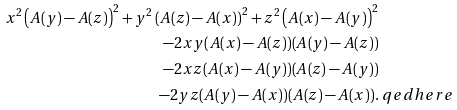Convert formula to latex. <formula><loc_0><loc_0><loc_500><loc_500>x ^ { 2 } \left ( A ( y ) - A ( z ) \right ) ^ { 2 } + y ^ { 2 } \left ( A ( z ) - A ( x ) \right ) ^ { 2 } + z ^ { 2 } \left ( A ( x ) - A ( y ) \right ) ^ { 2 } & \\ - 2 x y ( A ( x ) - A ( z ) ) ( A ( y ) - A ( z ) ) & \\ - 2 x z ( A ( x ) - A ( y ) ) ( A ( z ) - A ( y ) ) & \\ - 2 y z ( A ( y ) - A ( x ) ) ( A ( z ) - A ( x ) ) . & \ q e d h e r e</formula> 